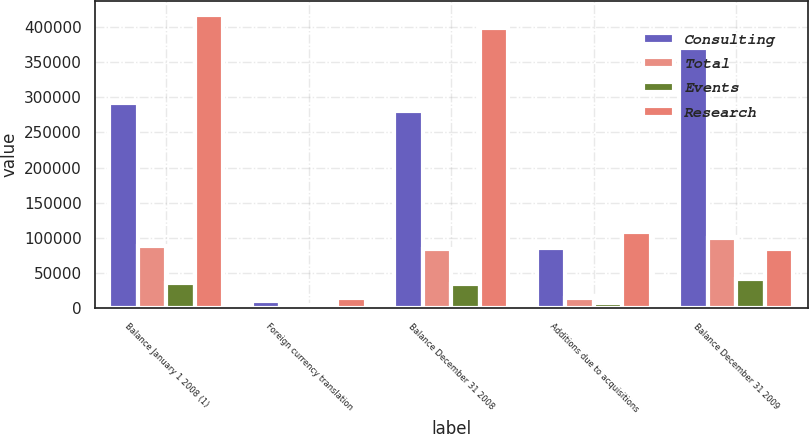Convert chart. <chart><loc_0><loc_0><loc_500><loc_500><stacked_bar_chart><ecel><fcel>Balance January 1 2008 (1)<fcel>Foreign currency translation<fcel>Balance December 31 2008<fcel>Additions due to acquisitions<fcel>Balance December 31 2009<nl><fcel>Consulting<fcel>291281<fcel>10600<fcel>280161<fcel>86083<fcel>370630<nl><fcel>Total<fcel>88425<fcel>4377<fcel>84048<fcel>15262<fcel>100744<nl><fcel>Events<fcel>36475<fcel>107<fcel>34528<fcel>7637<fcel>42238<nl><fcel>Research<fcel>416181<fcel>15084<fcel>398737<fcel>108982<fcel>84048<nl></chart> 